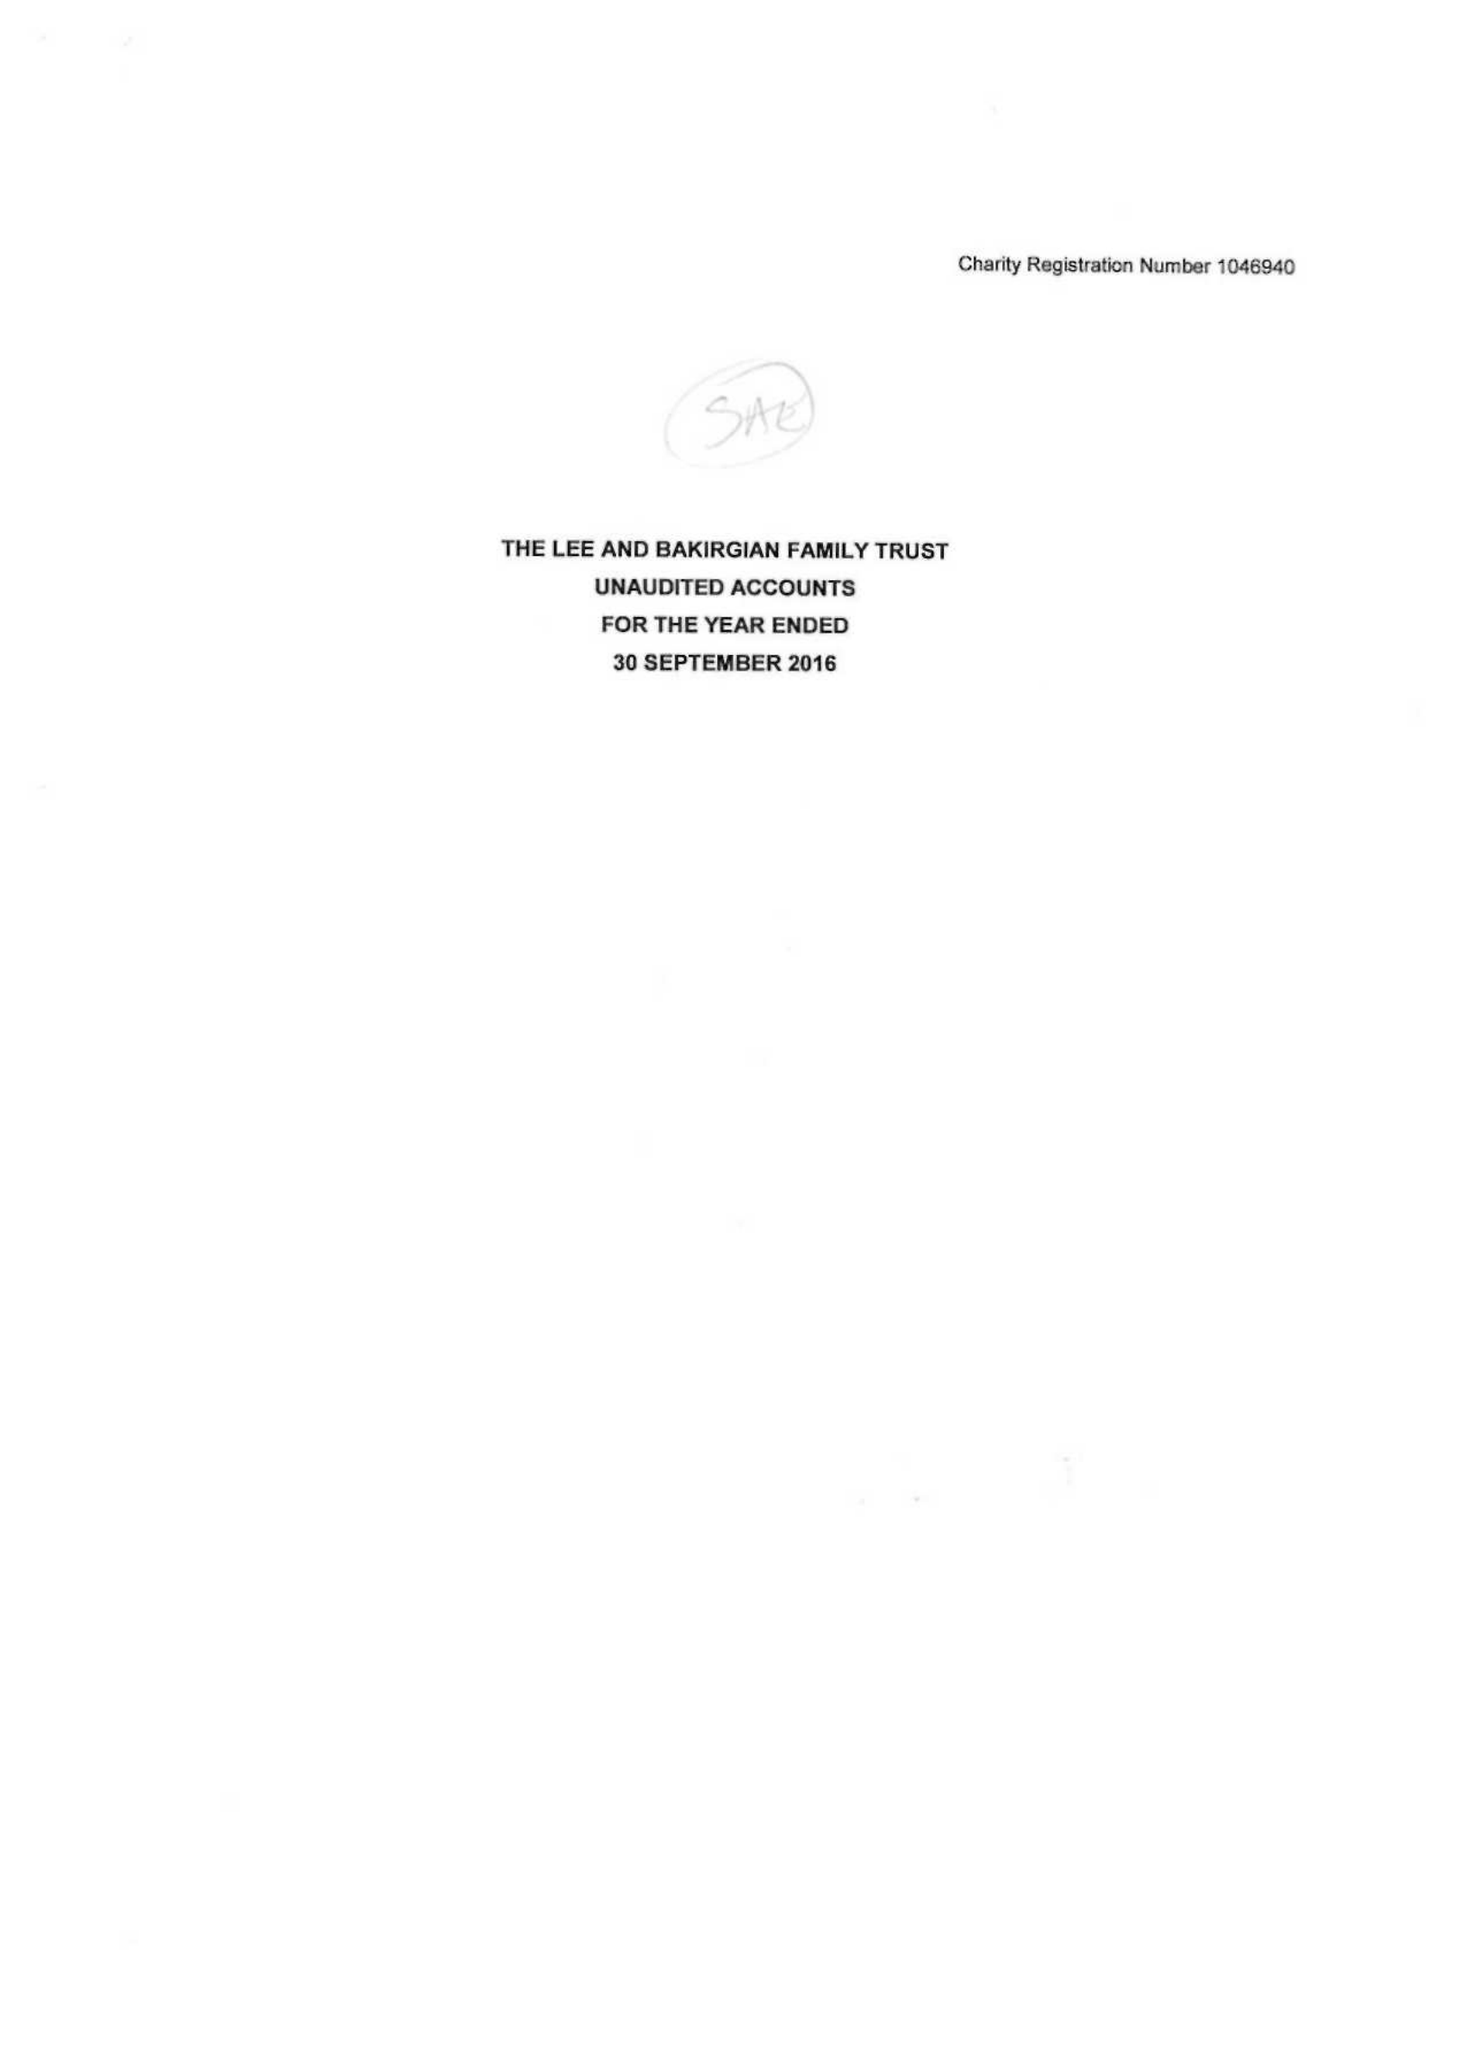What is the value for the report_date?
Answer the question using a single word or phrase. 2016-09-30 